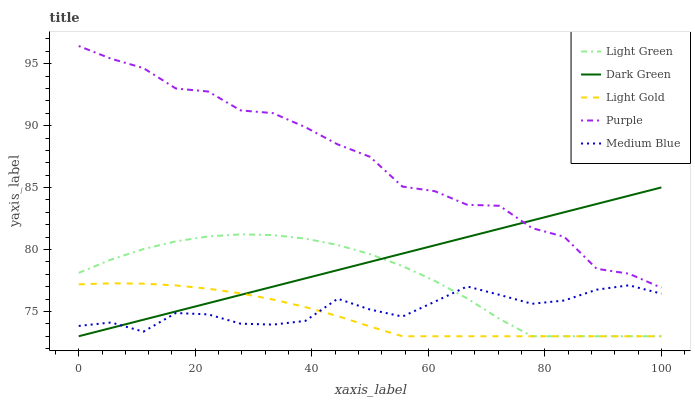Does Medium Blue have the minimum area under the curve?
Answer yes or no. No. Does Medium Blue have the maximum area under the curve?
Answer yes or no. No. Is Medium Blue the smoothest?
Answer yes or no. No. Is Medium Blue the roughest?
Answer yes or no. No. Does Medium Blue have the lowest value?
Answer yes or no. No. Does Light Gold have the highest value?
Answer yes or no. No. Is Light Gold less than Purple?
Answer yes or no. Yes. Is Purple greater than Medium Blue?
Answer yes or no. Yes. Does Light Gold intersect Purple?
Answer yes or no. No. 